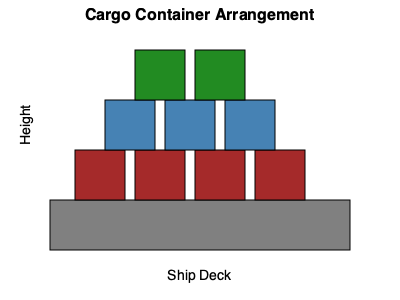Given the spatial arrangement of cargo containers on the ship deck as shown in the diagram, what is the maximum number of additional green containers that can be safely stacked while maintaining stability and not exceeding the height of the tallest stack? To determine the maximum number of additional green containers that can be safely stacked, we need to follow these steps:

1. Analyze the current arrangement:
   - Brown containers (bottom row): 4
   - Blue containers (middle row): 3
   - Green containers (top row): 2

2. Identify the height of the tallest stack:
   - The tallest stack has 3 containers (1 brown + 1 blue + 1 green)

3. Determine available spaces for additional green containers:
   - There are 4 stacks in total
   - 2 stacks already have green containers
   - 2 stacks (above the leftmost and rightmost brown containers) have space for green containers

4. Calculate the number of green containers that can be added:
   - Left stack: Can add 1 green container (to match the height of the tallest stack)
   - Right stack: Can add 2 green containers (to match the height of the tallest stack)

5. Sum up the additional green containers:
   - Total additional green containers = 1 + 2 = 3

Therefore, 3 additional green containers can be safely stacked while maintaining stability and not exceeding the height of the tallest stack.
Answer: 3 